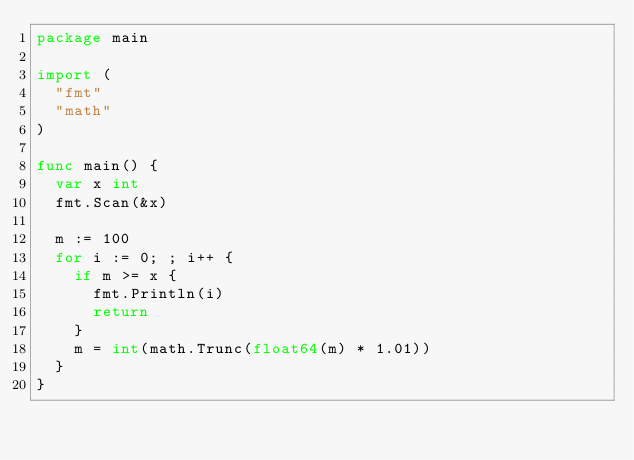<code> <loc_0><loc_0><loc_500><loc_500><_Go_>package main

import (
	"fmt"
	"math"
)

func main() {
	var x int
	fmt.Scan(&x)

	m := 100
	for i := 0; ; i++ {
		if m >= x {
			fmt.Println(i)
			return
		}
		m = int(math.Trunc(float64(m) * 1.01))
	}
}
</code> 